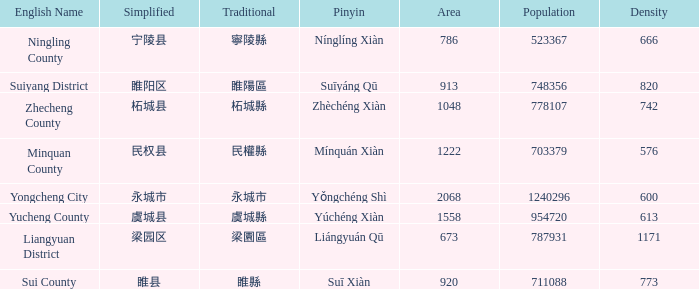What is the traditional form for 永城市? 永城市. 